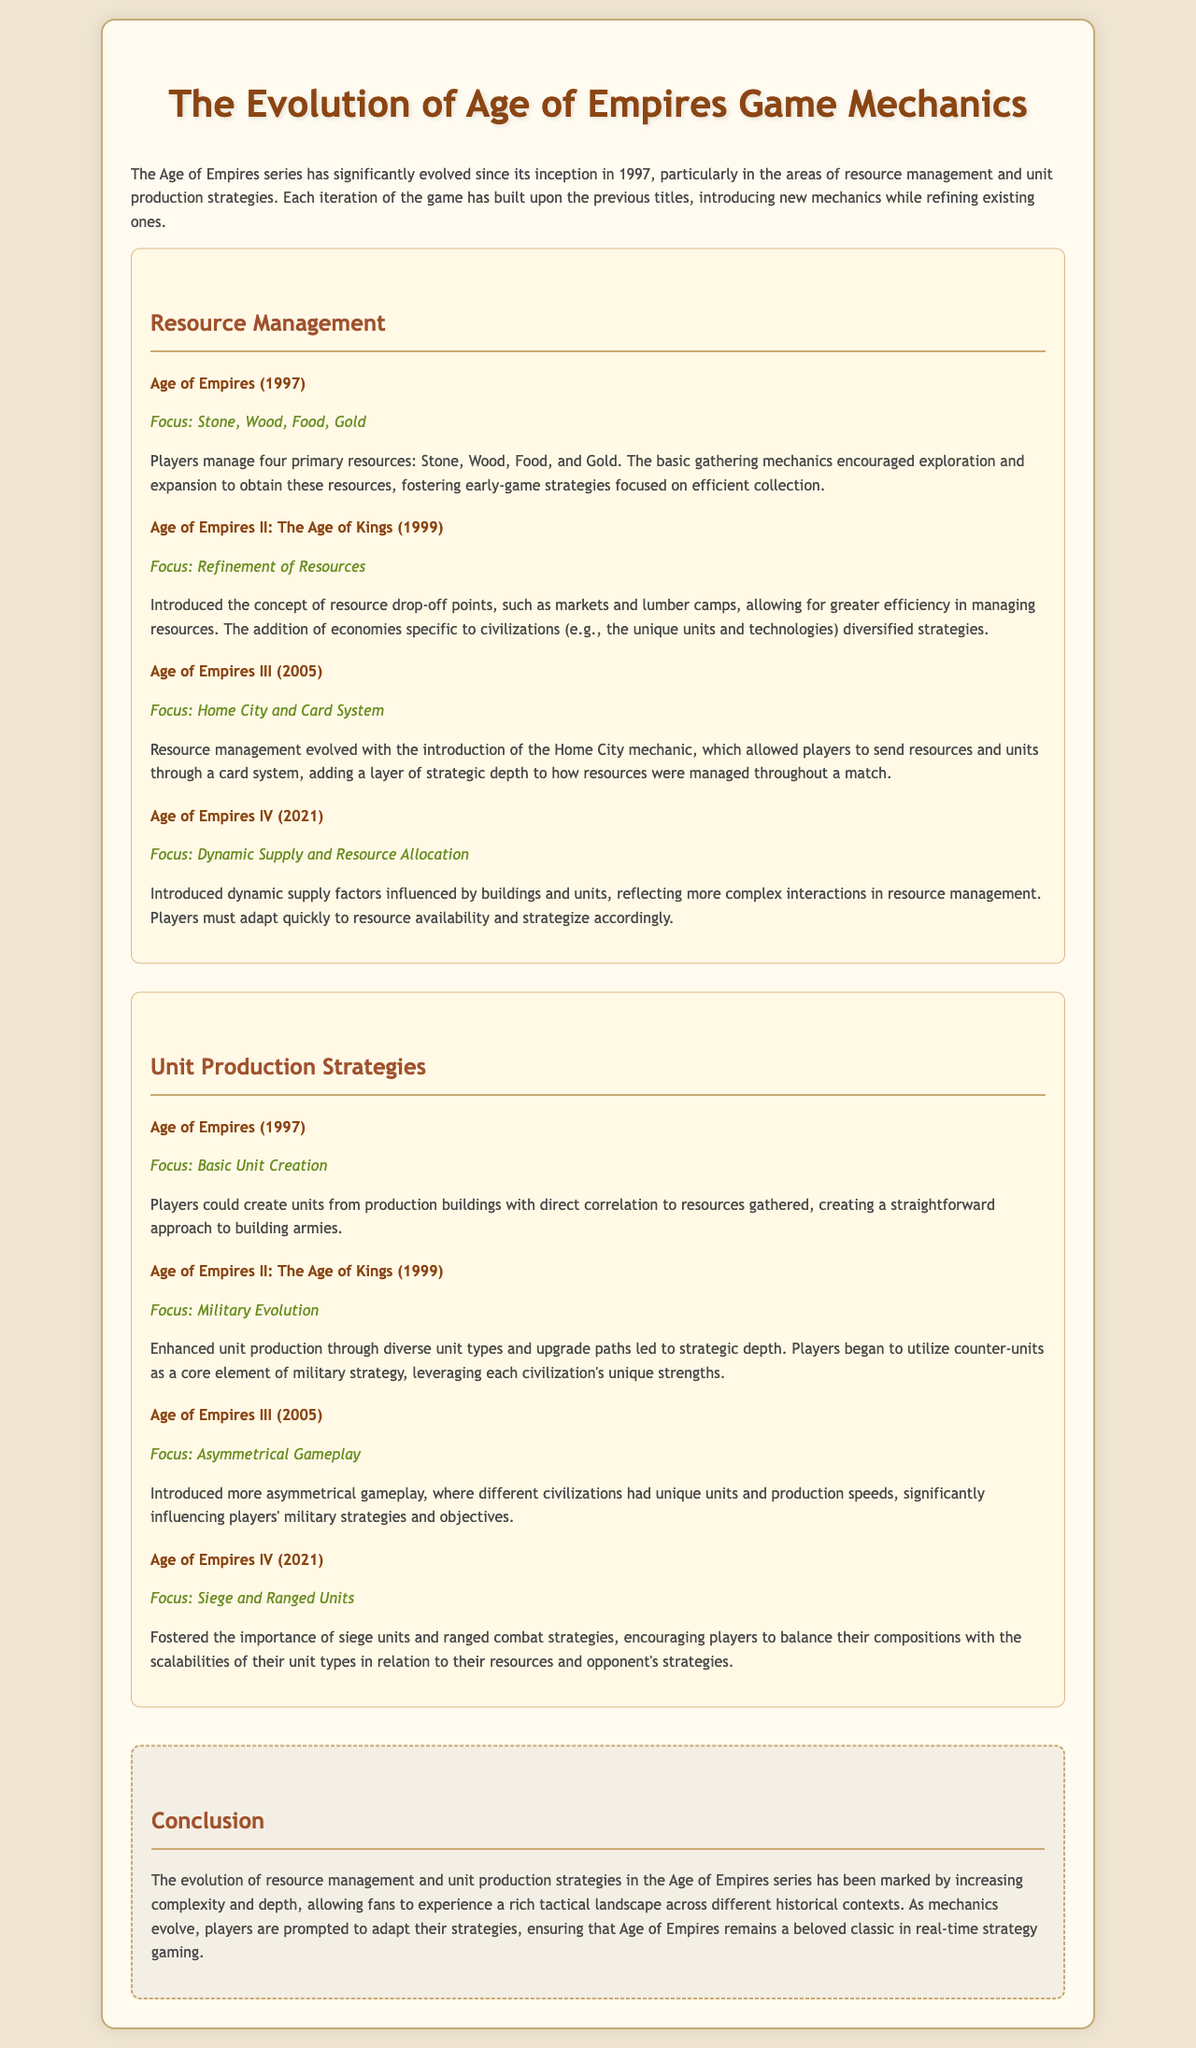What is the first game in the Age of Empires series? The first game listed in the document is "Age of Empires" (1997).
Answer: Age of Empires Which resource was introduced in Age of Empires II along with drop-off points? The document states that Age of Empires II introduced refinement of resources and drop-off points were mentioned.
Answer: Drop-off points What unique system was introduced in Age of Empires III for resource management? The Home City mechanic and card system for sending resources and units were introduced in Age of Empires III.
Answer: Home City What focus did Age of Empires IV have regarding resource allocation? Age of Empires IV focused on dynamic supply and resource allocation, showcasing interactions in resource management.
Answer: Dynamic Supply Which game emphasized the importance of siege units and ranged combat? The fourth game in the series, Age of Empires IV, emphasized siege units and ranged combat strategies.
Answer: Age of Empires IV How many primary resources were players managing in the first Age of Empires game? The document specifies that players managed four primary resources in the first game.
Answer: Four What strategy became central to military tactics in Age of Empires II? The document states that counter-units became a core element of military strategy in Age of Empires II.
Answer: Counter-units What did Age of Empires III introduce that affected unit production speeds? Asymmetrical gameplay affected unit production speeds and strategy in Age of Empires III.
Answer: Asymmetrical Gameplay What is the effectiveness focus for players in Age of Empires IV? Players need to balance unit compositions concerning their resources and opponent's strategies in Age of Empires IV.
Answer: Balance 